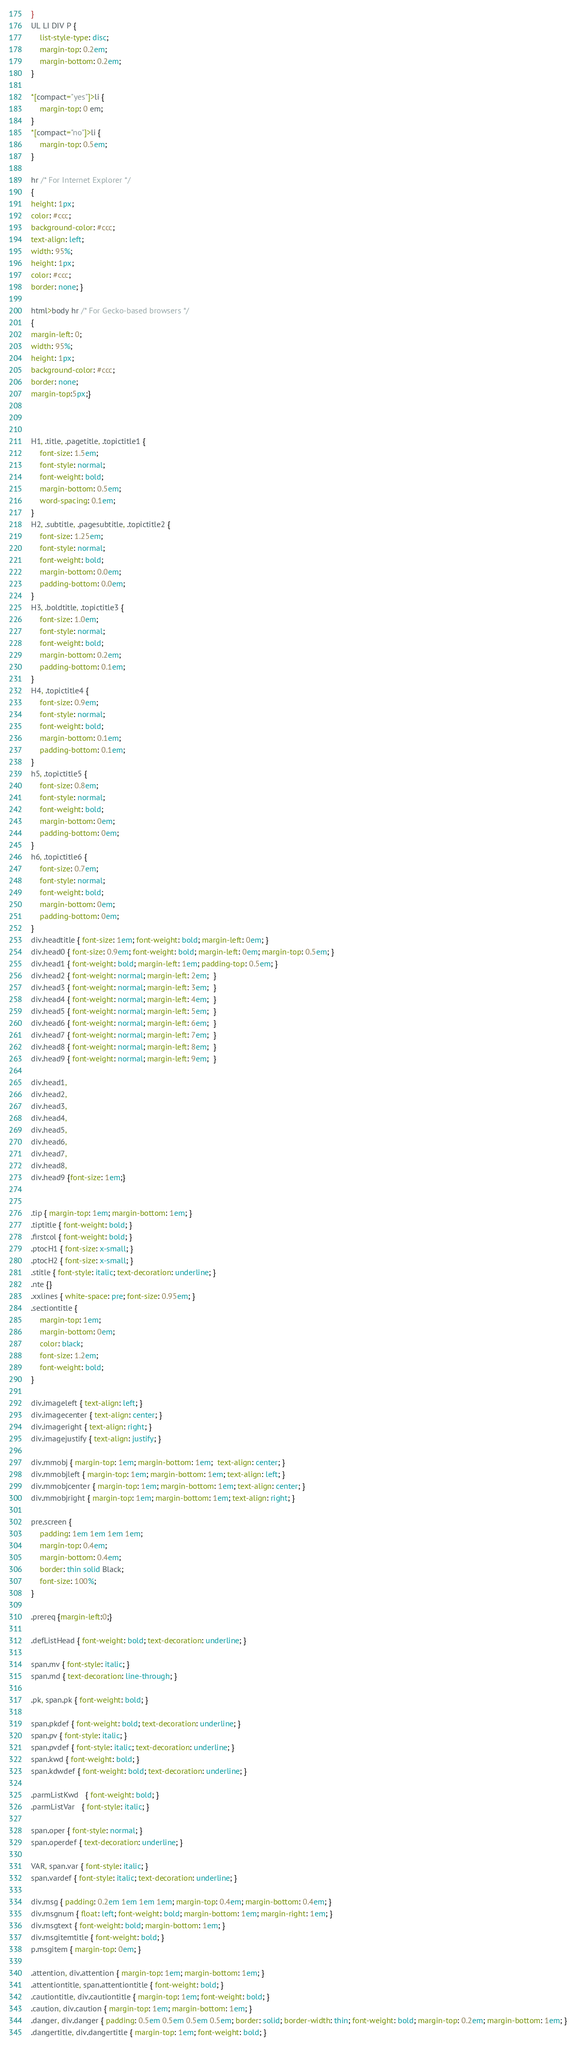<code> <loc_0><loc_0><loc_500><loc_500><_CSS_>}
UL LI DIV P {
	list-style-type: disc;
	margin-top: 0.2em;
	margin-bottom: 0.2em;
} 

*[compact="yes"]>li {
	margin-top: 0 em;
}
*[compact="no"]>li {
	margin-top: 0.5em;
}

hr /* For Internet Explorer */
{
height: 1px;
color: #ccc;
background-color: #ccc;
text-align: left; 
width: 95%; 
height: 1px; 
color: #ccc; 
border: none; } 

html>body hr /* For Gecko-based browsers */
{ 
margin-left: 0; 
width: 95%; 
height: 1px; 
background-color: #ccc; 
border: none; 
margin-top:5px;} 



H1, .title, .pagetitle, .topictitle1 {
	font-size: 1.5em;
	font-style: normal;
	font-weight: bold;
	margin-bottom: 0.5em;
	word-spacing: 0.1em;
}
H2, .subtitle, .pagesubtitle, .topictitle2 {
    font-size: 1.25em;
	font-style: normal;
	font-weight: bold;
	margin-bottom: 0.0em;
	padding-bottom: 0.0em;
}
H3, .boldtitle, .topictitle3 {	
    font-size: 1.0em;
	font-style: normal;
	font-weight: bold;
	margin-bottom: 0.2em;
	padding-bottom: 0.1em;
}
H4, .topictitle4 {
    font-size: 0.9em;
	font-style: normal;
	font-weight: bold;
	margin-bottom: 0.1em;
	padding-bottom: 0.1em;
}
h5, .topictitle5 {
    font-size: 0.8em;
	font-style: normal;
	font-weight: bold;
	margin-bottom: 0em;
	padding-bottom: 0em;
}
h6, .topictitle6 {
    font-size: 0.7em;
	font-style: normal;
	font-weight: bold;
	margin-bottom: 0em;
	padding-bottom: 0em;
}
div.headtitle { font-size: 1em; font-weight: bold; margin-left: 0em; }
div.head0 { font-size: 0.9em; font-weight: bold; margin-left: 0em; margin-top: 0.5em; }
div.head1 { font-weight: bold; margin-left: 1em; padding-top: 0.5em; }
div.head2 { font-weight: normal; margin-left: 2em;  }
div.head3 { font-weight: normal; margin-left: 3em;  }
div.head4 { font-weight: normal; margin-left: 4em;  }
div.head5 { font-weight: normal; margin-left: 5em;  }
div.head6 { font-weight: normal; margin-left: 6em;  }
div.head7 { font-weight: normal; margin-left: 7em;  }
div.head8 { font-weight: normal; margin-left: 8em;  }
div.head9 { font-weight: normal; margin-left: 9em;  }

div.head1,
div.head2,
div.head3,
div.head4,
div.head5,
div.head6,
div.head7,
div.head8,
div.head9 {font-size: 1em;} 


.tip { margin-top: 1em; margin-bottom: 1em; }
.tiptitle { font-weight: bold; }
.firstcol { font-weight: bold; }
.ptocH1 { font-size: x-small; }
.ptocH2 { font-size: x-small; }
.stitle { font-style: italic; text-decoration: underline; }
.nte {}
.xxlines { white-space: pre; font-size: 0.95em; }
.sectiontitle {
	margin-top: 1em;
	margin-bottom: 0em;
	color: black;
	font-size: 1.2em;
	font-weight: bold;
}

div.imageleft { text-align: left; }
div.imagecenter { text-align: center; }
div.imageright { text-align: right; }
div.imagejustify { text-align: justify; }

div.mmobj { margin-top: 1em; margin-bottom: 1em;  text-align: center; }
div.mmobjleft { margin-top: 1em; margin-bottom: 1em; text-align: left; }
div.mmobjcenter { margin-top: 1em; margin-bottom: 1em; text-align: center; }
div.mmobjright { margin-top: 1em; margin-bottom: 1em; text-align: right; }

pre.screen {
	padding: 1em 1em 1em 1em;
	margin-top: 0.4em;
	margin-bottom: 0.4em;
	border: thin solid Black;
	font-size: 100%;
}

.prereq {margin-left:0;}

.defListHead { font-weight: bold; text-decoration: underline; }

span.mv { font-style: italic; }
span.md { text-decoration: line-through; }

.pk, span.pk { font-weight: bold; }

span.pkdef { font-weight: bold; text-decoration: underline; }
span.pv { font-style: italic; }
span.pvdef { font-style: italic; text-decoration: underline; }
span.kwd { font-weight: bold; }
span.kdwdef { font-weight: bold; text-decoration: underline; }

.parmListKwd   { font-weight: bold; }
.parmListVar   { font-style: italic; }

span.oper { font-style: normal; }
span.operdef { text-decoration: underline; }

VAR, span.var { font-style: italic; }
span.vardef { font-style: italic; text-decoration: underline; }
		  
div.msg { padding: 0.2em 1em 1em 1em; margin-top: 0.4em; margin-bottom: 0.4em; }
div.msgnum { float: left; font-weight: bold; margin-bottom: 1em; margin-right: 1em; }
div.msgtext { font-weight: bold; margin-bottom: 1em; }
div.msgitemtitle { font-weight: bold; }
p.msgitem { margin-top: 0em; }

.attention, div.attention { margin-top: 1em; margin-bottom: 1em; }
.attentiontitle, span.attentiontitle { font-weight: bold; }
.cautiontitle, div.cautiontitle { margin-top: 1em; font-weight: bold; }
.caution, div.caution { margin-top: 1em; margin-bottom: 1em; }
.danger, div.danger { padding: 0.5em 0.5em 0.5em 0.5em; border: solid; border-width: thin; font-weight: bold; margin-top: 0.2em; margin-bottom: 1em; }
.dangertitle, div.dangertitle { margin-top: 1em; font-weight: bold; }
</code> 